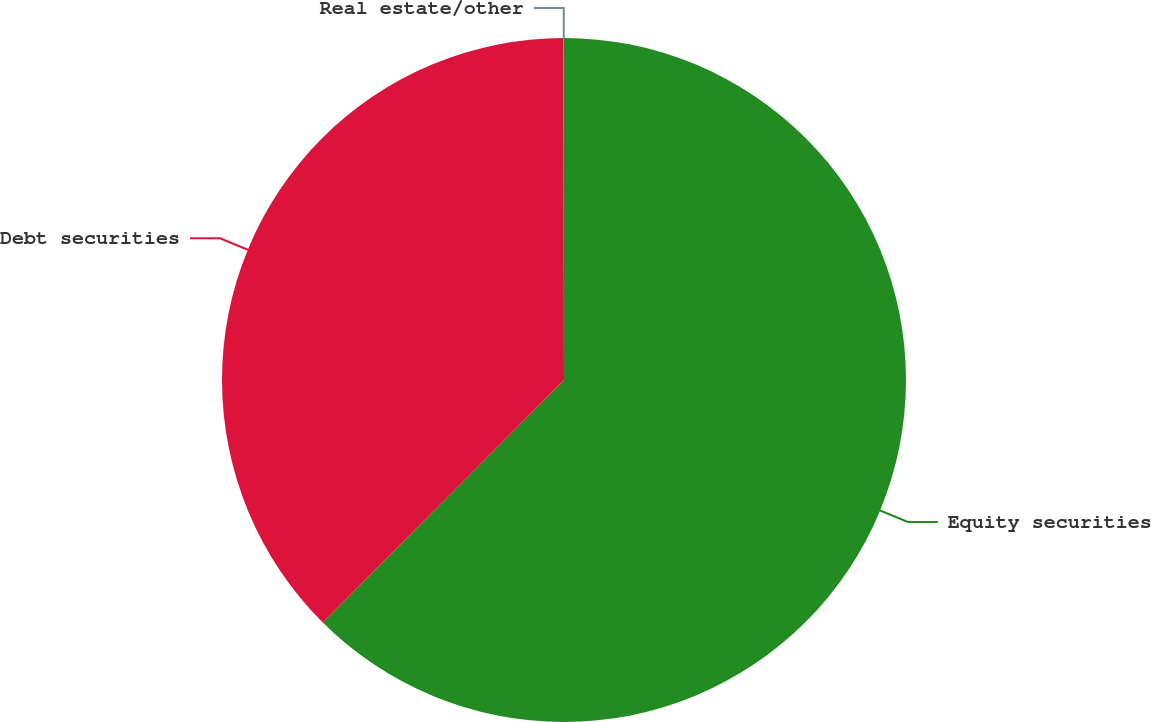<chart> <loc_0><loc_0><loc_500><loc_500><pie_chart><fcel>Equity securities<fcel>Debt securities<fcel>Real estate/other<nl><fcel>62.46%<fcel>37.52%<fcel>0.02%<nl></chart> 